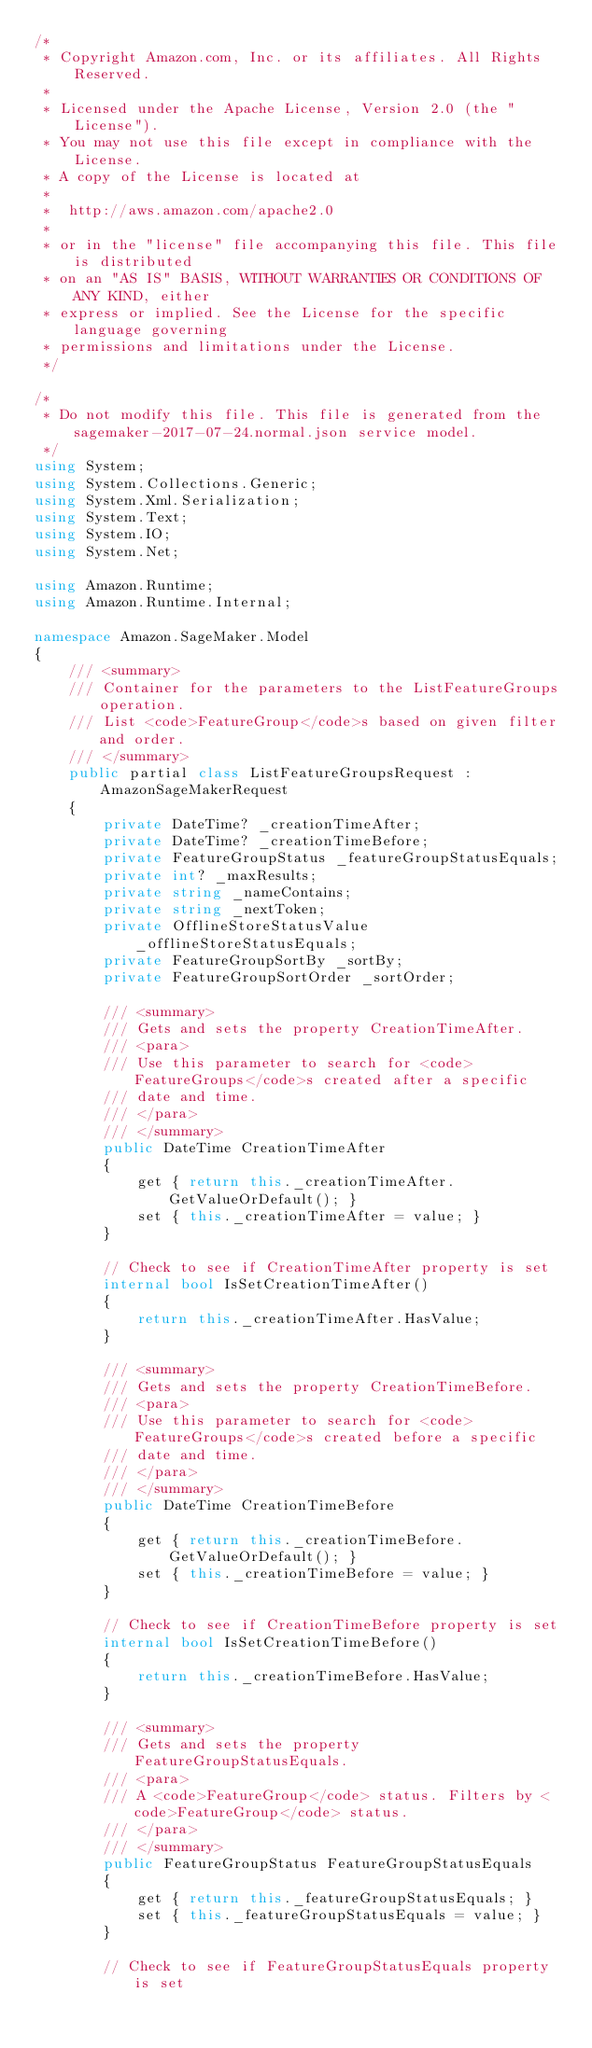Convert code to text. <code><loc_0><loc_0><loc_500><loc_500><_C#_>/*
 * Copyright Amazon.com, Inc. or its affiliates. All Rights Reserved.
 * 
 * Licensed under the Apache License, Version 2.0 (the "License").
 * You may not use this file except in compliance with the License.
 * A copy of the License is located at
 * 
 *  http://aws.amazon.com/apache2.0
 * 
 * or in the "license" file accompanying this file. This file is distributed
 * on an "AS IS" BASIS, WITHOUT WARRANTIES OR CONDITIONS OF ANY KIND, either
 * express or implied. See the License for the specific language governing
 * permissions and limitations under the License.
 */

/*
 * Do not modify this file. This file is generated from the sagemaker-2017-07-24.normal.json service model.
 */
using System;
using System.Collections.Generic;
using System.Xml.Serialization;
using System.Text;
using System.IO;
using System.Net;

using Amazon.Runtime;
using Amazon.Runtime.Internal;

namespace Amazon.SageMaker.Model
{
    /// <summary>
    /// Container for the parameters to the ListFeatureGroups operation.
    /// List <code>FeatureGroup</code>s based on given filter and order.
    /// </summary>
    public partial class ListFeatureGroupsRequest : AmazonSageMakerRequest
    {
        private DateTime? _creationTimeAfter;
        private DateTime? _creationTimeBefore;
        private FeatureGroupStatus _featureGroupStatusEquals;
        private int? _maxResults;
        private string _nameContains;
        private string _nextToken;
        private OfflineStoreStatusValue _offlineStoreStatusEquals;
        private FeatureGroupSortBy _sortBy;
        private FeatureGroupSortOrder _sortOrder;

        /// <summary>
        /// Gets and sets the property CreationTimeAfter. 
        /// <para>
        /// Use this parameter to search for <code>FeatureGroups</code>s created after a specific
        /// date and time.
        /// </para>
        /// </summary>
        public DateTime CreationTimeAfter
        {
            get { return this._creationTimeAfter.GetValueOrDefault(); }
            set { this._creationTimeAfter = value; }
        }

        // Check to see if CreationTimeAfter property is set
        internal bool IsSetCreationTimeAfter()
        {
            return this._creationTimeAfter.HasValue; 
        }

        /// <summary>
        /// Gets and sets the property CreationTimeBefore. 
        /// <para>
        /// Use this parameter to search for <code>FeatureGroups</code>s created before a specific
        /// date and time.
        /// </para>
        /// </summary>
        public DateTime CreationTimeBefore
        {
            get { return this._creationTimeBefore.GetValueOrDefault(); }
            set { this._creationTimeBefore = value; }
        }

        // Check to see if CreationTimeBefore property is set
        internal bool IsSetCreationTimeBefore()
        {
            return this._creationTimeBefore.HasValue; 
        }

        /// <summary>
        /// Gets and sets the property FeatureGroupStatusEquals. 
        /// <para>
        /// A <code>FeatureGroup</code> status. Filters by <code>FeatureGroup</code> status. 
        /// </para>
        /// </summary>
        public FeatureGroupStatus FeatureGroupStatusEquals
        {
            get { return this._featureGroupStatusEquals; }
            set { this._featureGroupStatusEquals = value; }
        }

        // Check to see if FeatureGroupStatusEquals property is set</code> 